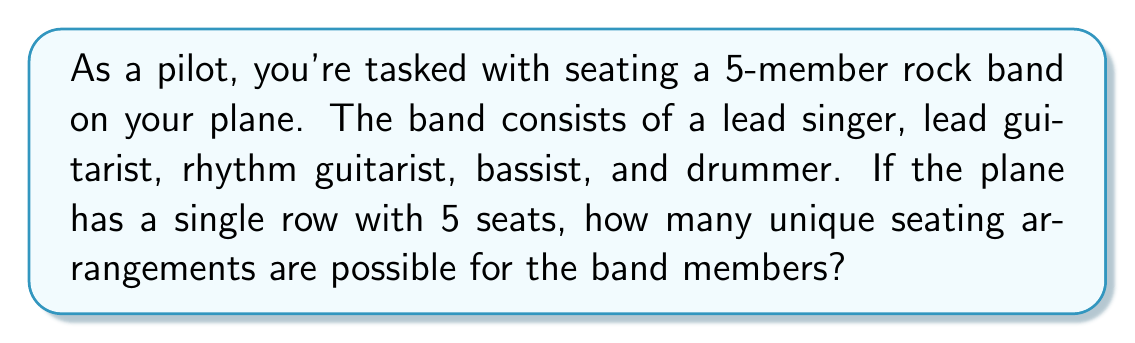Provide a solution to this math problem. Let's approach this step-by-step:

1) This is a permutation problem. We need to arrange 5 distinct people in 5 distinct seats.

2) For the first seat, we have 5 choices (any of the 5 band members can sit there).

3) For the second seat, we have 4 choices remaining.

4) For the third seat, we have 3 choices remaining.

5) For the fourth seat, we have 2 choices remaining.

6) For the last seat, we only have 1 choice left.

7) According to the multiplication principle, we multiply these numbers together:

   $$ 5 \times 4 \times 3 \times 2 \times 1 = 120 $$

8) This is also known as 5 factorial, denoted as 5!:

   $$ 5! = 5 \times 4 \times 3 \times 2 \times 1 = 120 $$

Therefore, there are 120 unique seating arrangements possible for the rock band on your plane.
Answer: 120 